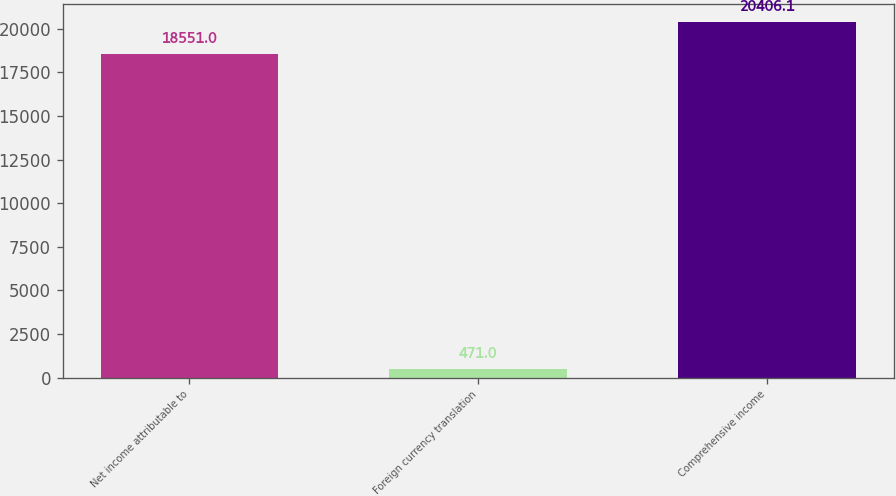Convert chart. <chart><loc_0><loc_0><loc_500><loc_500><bar_chart><fcel>Net income attributable to<fcel>Foreign currency translation<fcel>Comprehensive income<nl><fcel>18551<fcel>471<fcel>20406.1<nl></chart> 